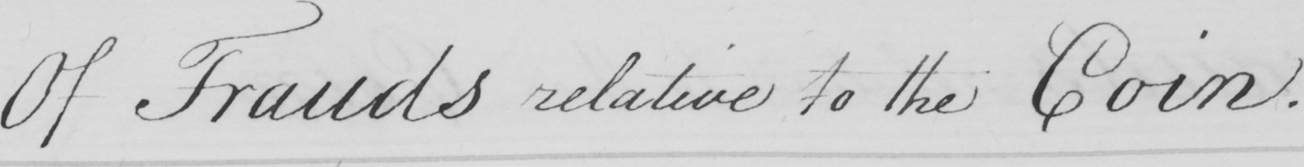Can you read and transcribe this handwriting? Of Frauds relative to the Coin. 